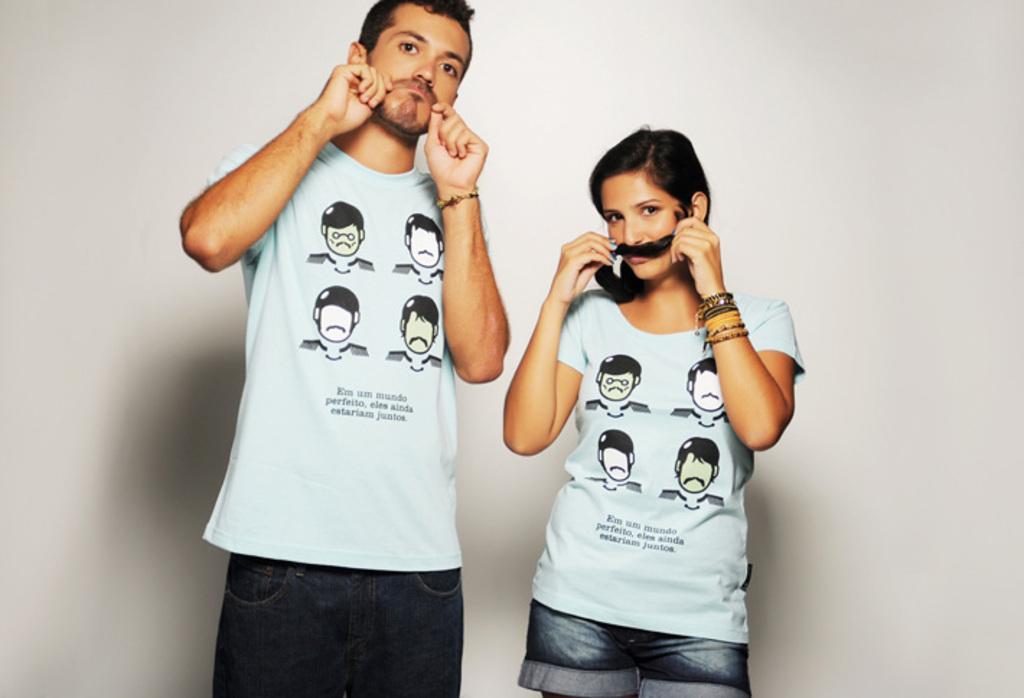Could you give a brief overview of what you see in this image? In this picture we can see two people. 